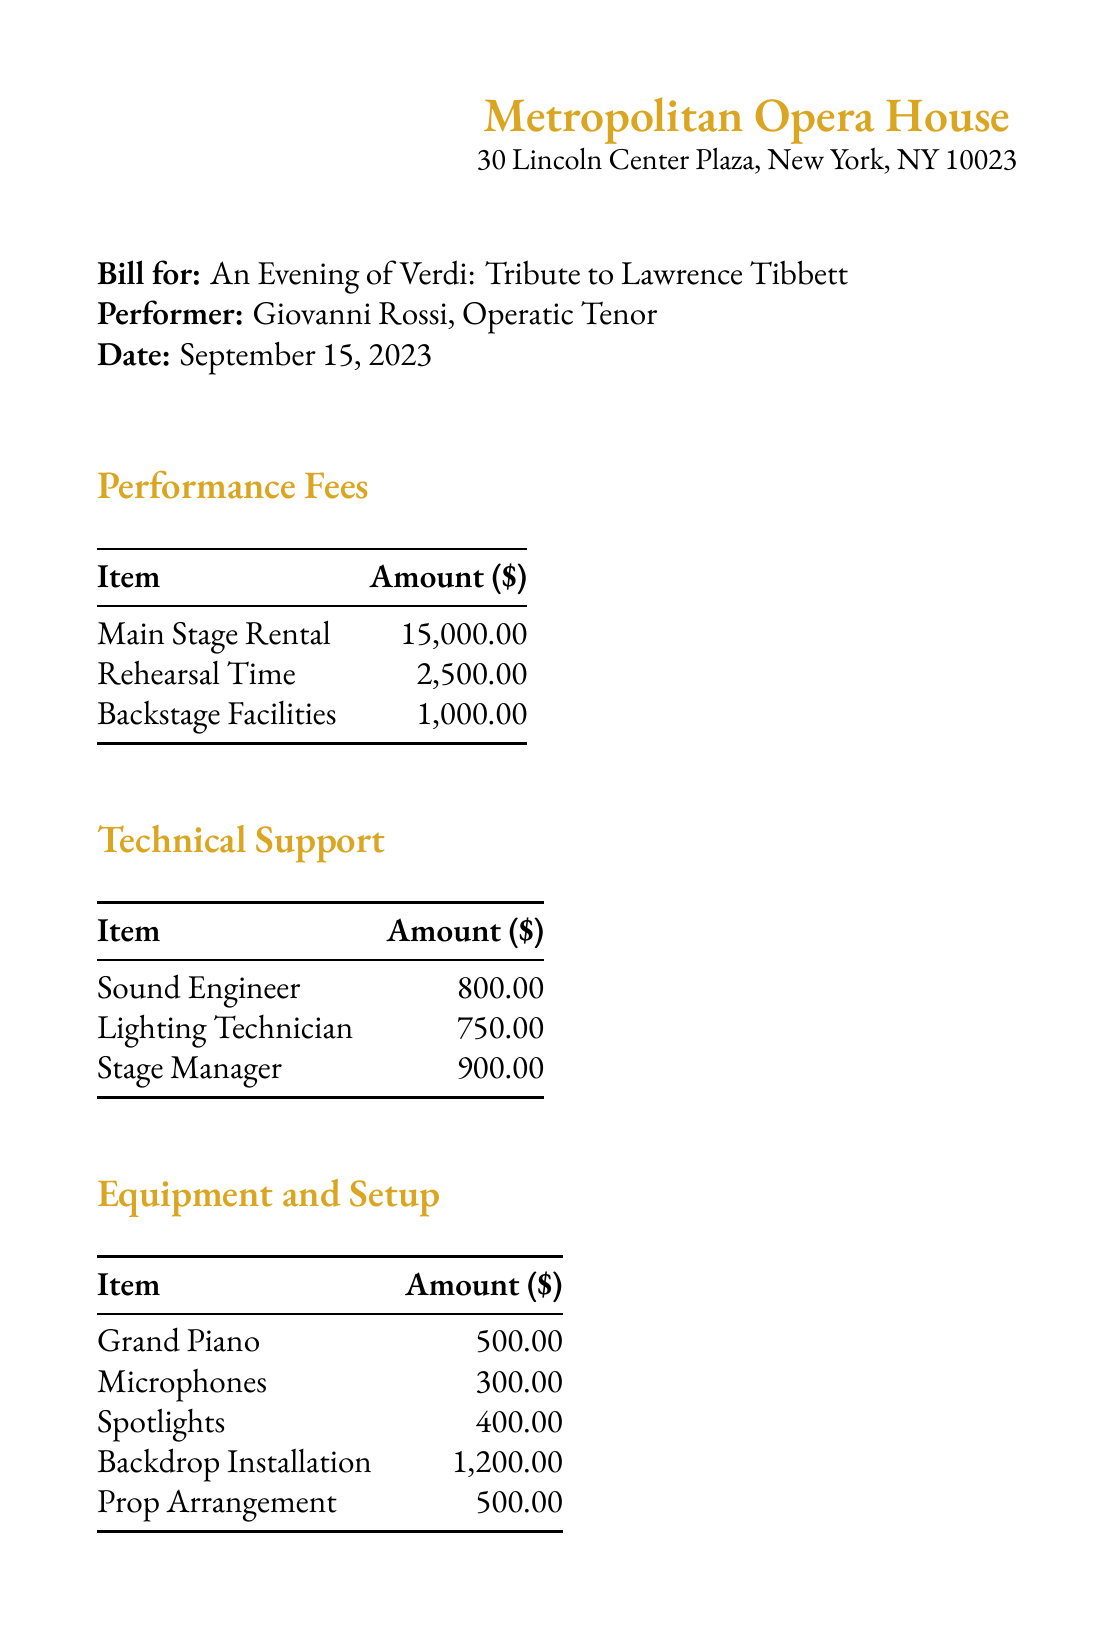What is the date of the performance? The date of the performance is clearly stated in the document.
Answer: September 15, 2023 Who is the performer? The document specifies the name of the performer involved in the event.
Answer: Giovanni Rossi What is the total due amount? The total due amount is listed at the end of the document after calculating the subtotal and tax.
Answer: $31,718.69 How much is the subtotal before tax? The subtotal amount is provided separately before the tax calculation in the document.
Answer: $29,150.00 What is the fee for the grand piano? The fee for the grand piano is outlined in the equipment section of the document.
Answer: $500.00 How much does marketing support cost? The cost of marketing support is mentioned under additional services in the document.
Answer: $2,000.00 What percentage is the tax? The tax percentage is explicitly mentioned in the document for clarity.
Answer: 8.875% What is included in technical support? The items listed under technical support are specified in the corresponding section of the document.
Answer: Sound Engineer, Lighting Technician, Stage Manager What is the total cost for ushers and security? The total cost for ushers and security can be calculated by adding both amounts listed in the additional services section.
Answer: $1,400.00 